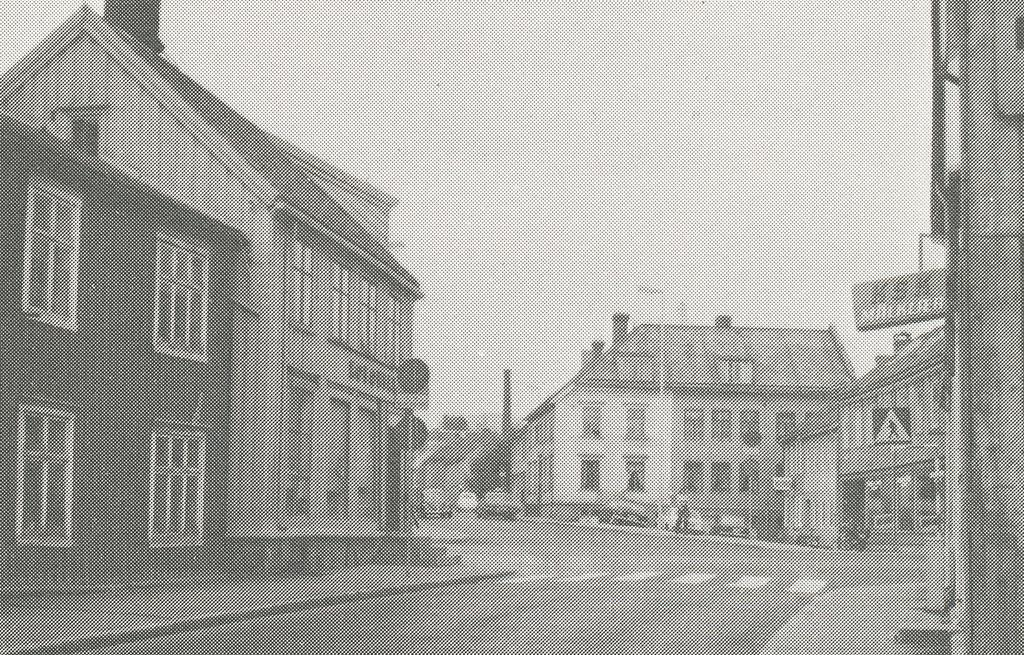<image>
Present a compact description of the photo's key features. An old street photo with a sihn saying KSK 